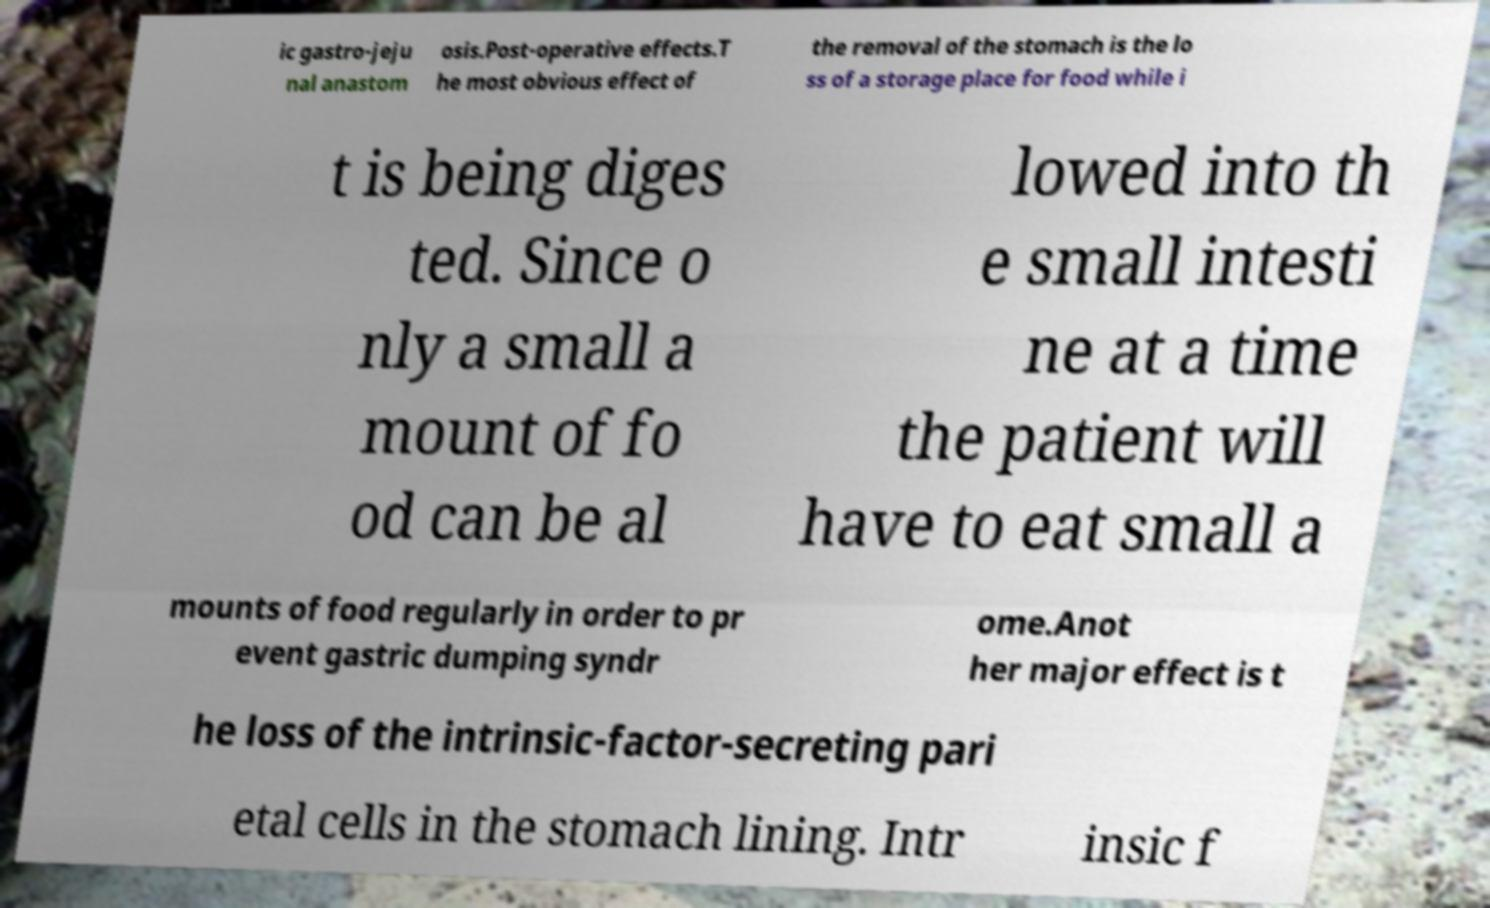Could you extract and type out the text from this image? ic gastro-jeju nal anastom osis.Post-operative effects.T he most obvious effect of the removal of the stomach is the lo ss of a storage place for food while i t is being diges ted. Since o nly a small a mount of fo od can be al lowed into th e small intesti ne at a time the patient will have to eat small a mounts of food regularly in order to pr event gastric dumping syndr ome.Anot her major effect is t he loss of the intrinsic-factor-secreting pari etal cells in the stomach lining. Intr insic f 